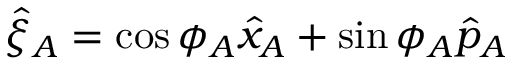<formula> <loc_0><loc_0><loc_500><loc_500>\hat { \xi } _ { A } = \cos \phi _ { A } \hat { x } _ { A } + \sin \phi _ { A } \hat { p } _ { A }</formula> 